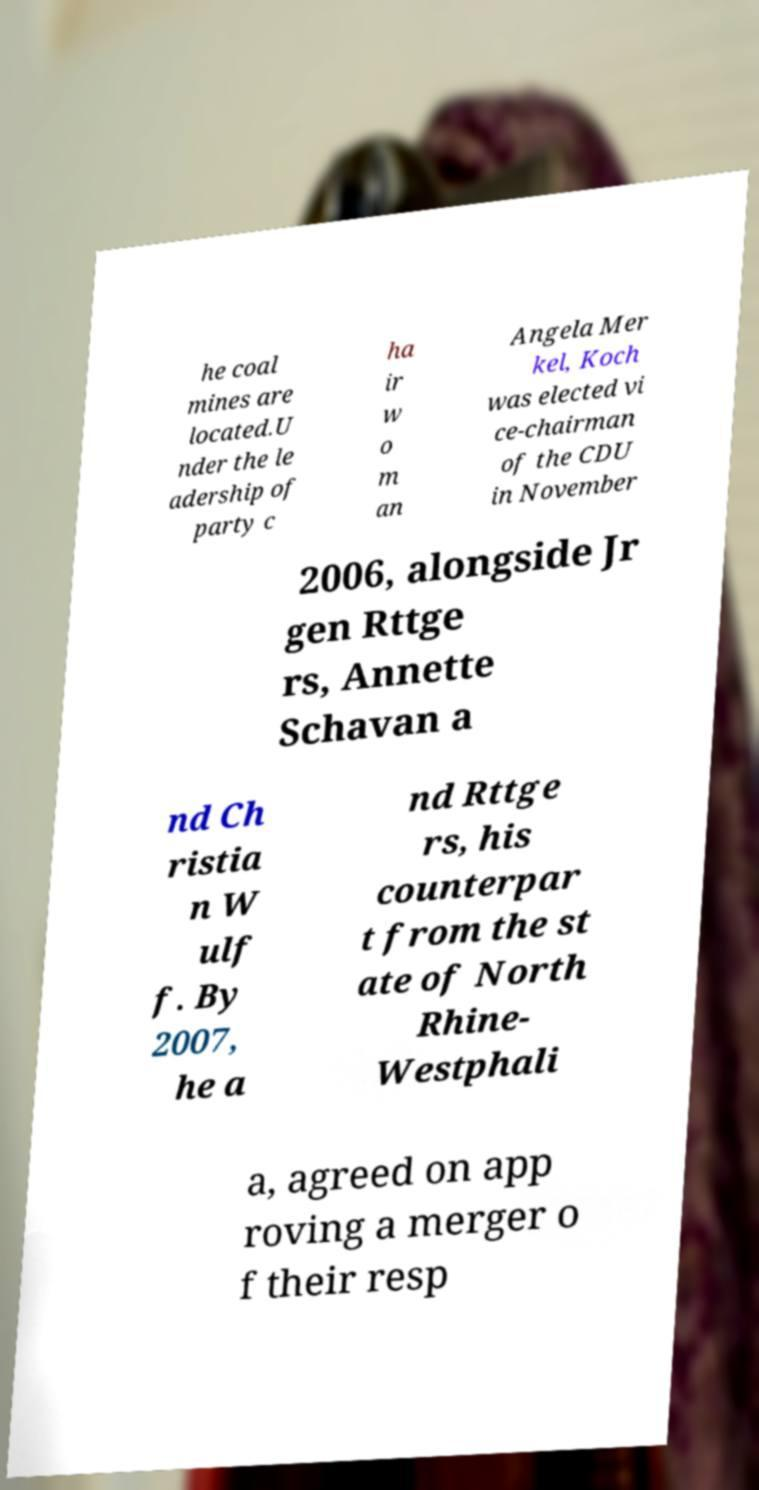I need the written content from this picture converted into text. Can you do that? he coal mines are located.U nder the le adership of party c ha ir w o m an Angela Mer kel, Koch was elected vi ce-chairman of the CDU in November 2006, alongside Jr gen Rttge rs, Annette Schavan a nd Ch ristia n W ulf f. By 2007, he a nd Rttge rs, his counterpar t from the st ate of North Rhine- Westphali a, agreed on app roving a merger o f their resp 